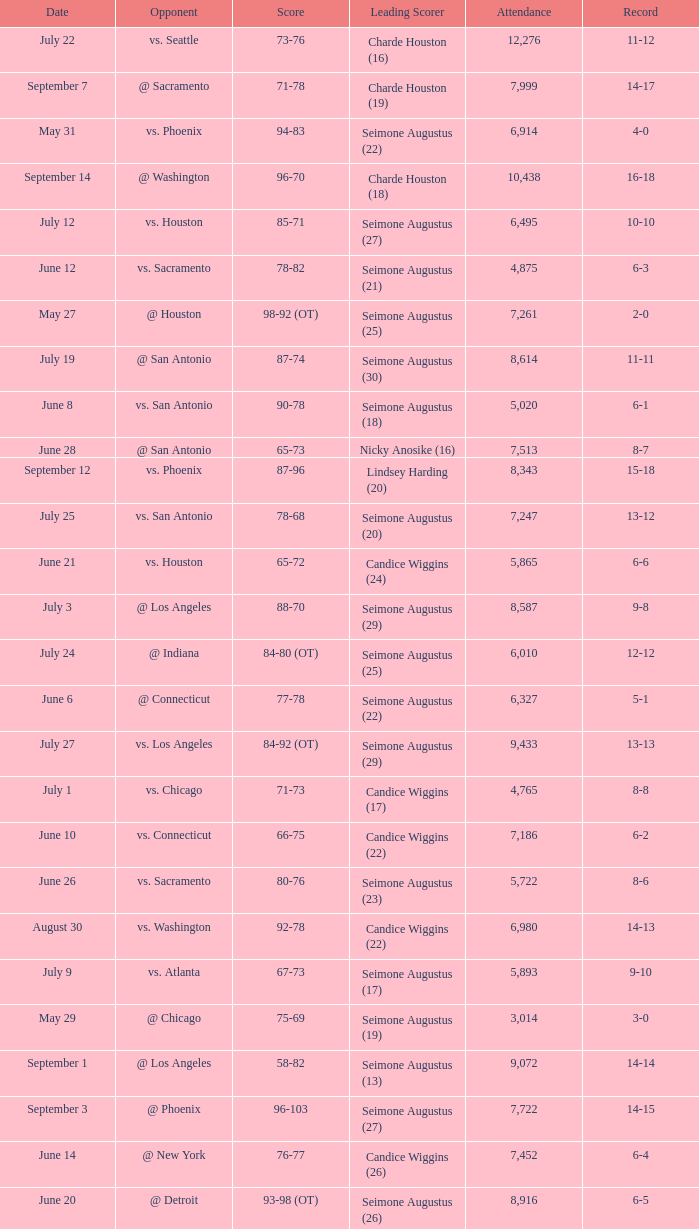Which Score has an Opponent of @ houston, and a Record of 2-0? 98-92 (OT). 